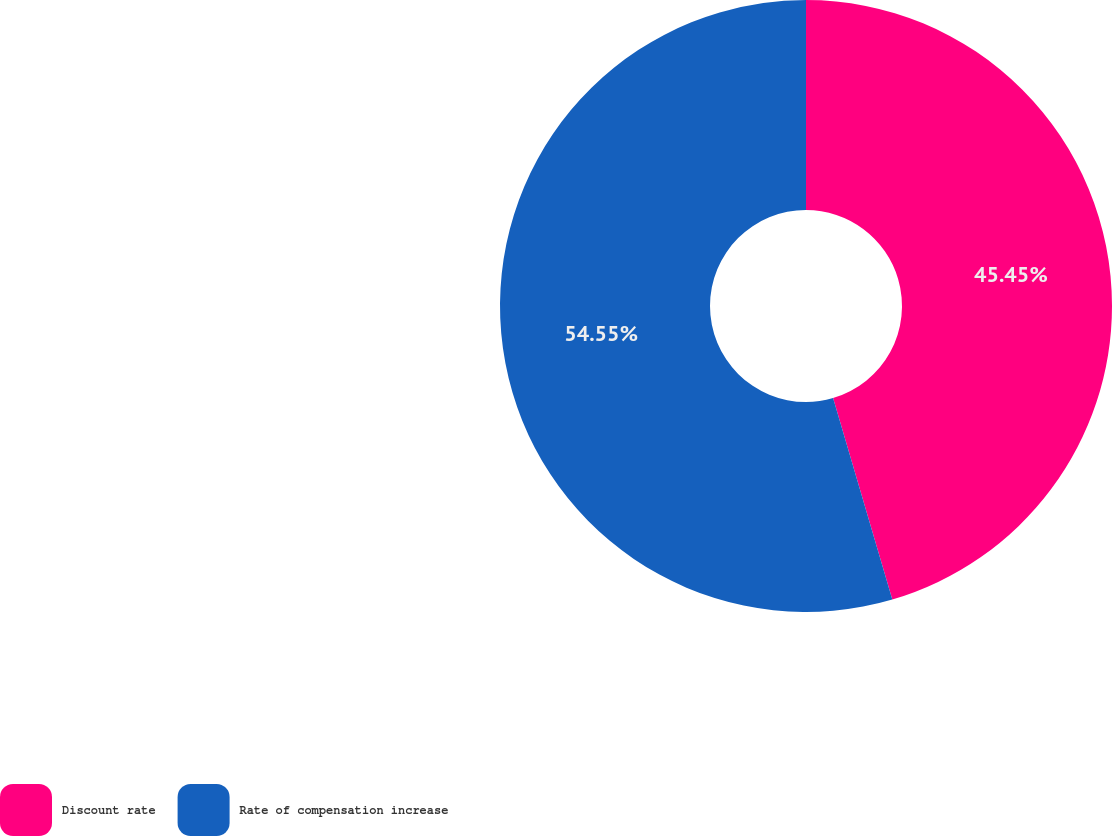<chart> <loc_0><loc_0><loc_500><loc_500><pie_chart><fcel>Discount rate<fcel>Rate of compensation increase<nl><fcel>45.45%<fcel>54.55%<nl></chart> 